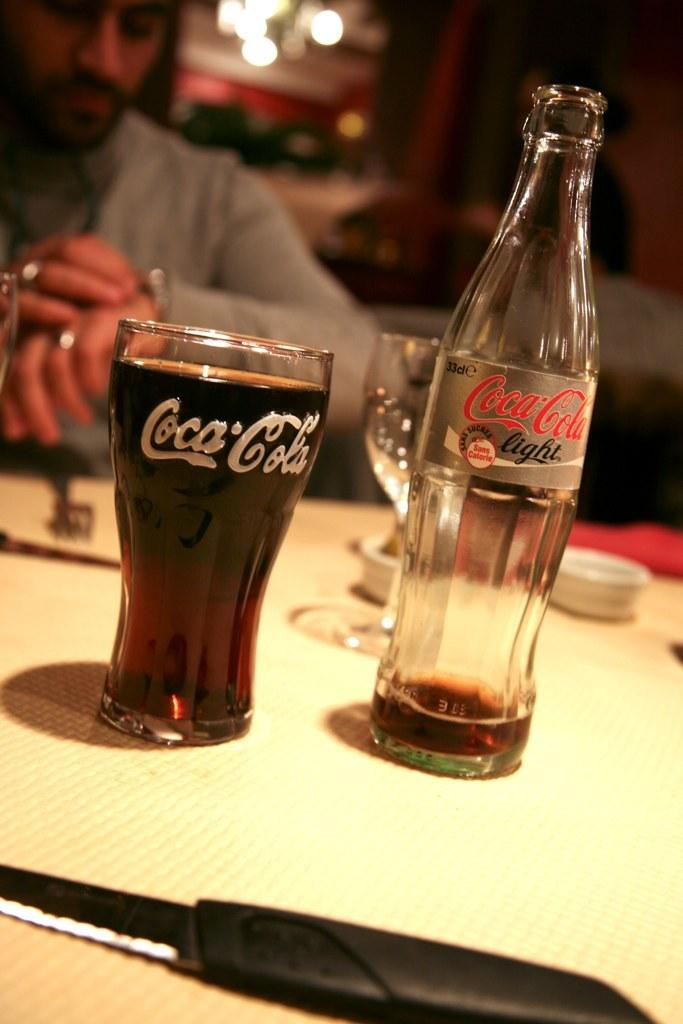<image>
Render a clear and concise summary of the photo. An empty bottle of Coca-Cola sits to the right of a full glass of Coca-Cola. 